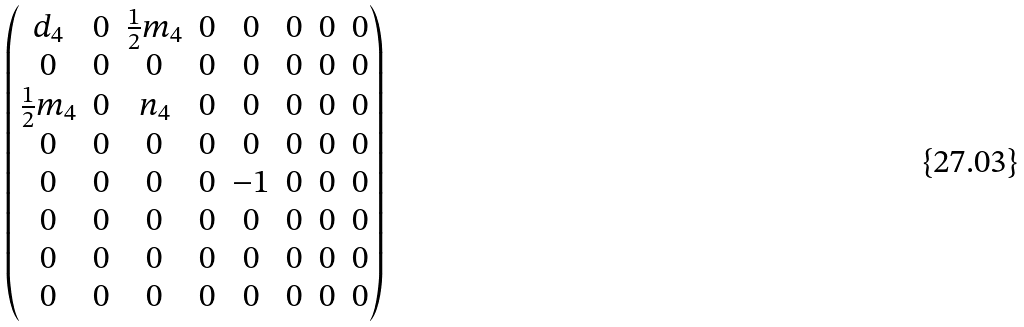Convert formula to latex. <formula><loc_0><loc_0><loc_500><loc_500>\begin{pmatrix} d _ { 4 } & 0 & \frac { 1 } { 2 } m _ { 4 } & 0 & 0 & 0 & 0 & 0 \\ 0 & 0 & 0 & 0 & 0 & 0 & 0 & 0 \\ \frac { 1 } { 2 } m _ { 4 } & 0 & n _ { 4 } & 0 & 0 & 0 & 0 & 0 \\ 0 & 0 & 0 & 0 & 0 & 0 & 0 & 0 \\ 0 & 0 & 0 & 0 & - 1 & 0 & 0 & 0 \\ 0 & 0 & 0 & 0 & 0 & 0 & 0 & 0 \\ 0 & 0 & 0 & 0 & 0 & 0 & 0 & 0 \\ 0 & 0 & 0 & 0 & 0 & 0 & 0 & 0 \end{pmatrix}</formula> 